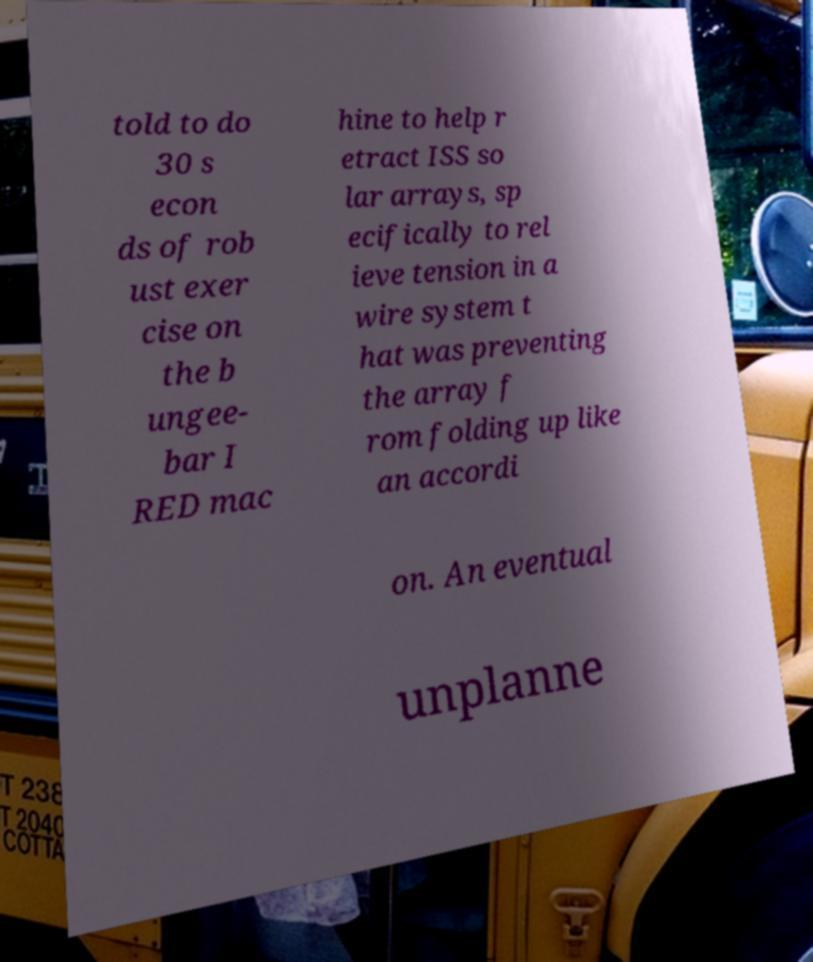Can you read and provide the text displayed in the image?This photo seems to have some interesting text. Can you extract and type it out for me? told to do 30 s econ ds of rob ust exer cise on the b ungee- bar I RED mac hine to help r etract ISS so lar arrays, sp ecifically to rel ieve tension in a wire system t hat was preventing the array f rom folding up like an accordi on. An eventual unplanne 